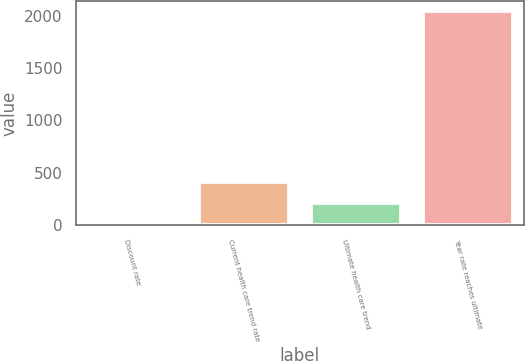Convert chart. <chart><loc_0><loc_0><loc_500><loc_500><bar_chart><fcel>Discount rate<fcel>Current health care trend rate<fcel>Ultimate health care trend<fcel>Year rate reaches ultimate<nl><fcel>3.9<fcel>411.32<fcel>207.61<fcel>2041<nl></chart> 